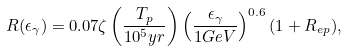<formula> <loc_0><loc_0><loc_500><loc_500>R ( \epsilon _ { \gamma } ) = 0 . 0 7 \zeta \left ( \frac { T _ { p } } { 1 0 ^ { 5 } y r } \right ) \left ( \frac { \epsilon _ { \gamma } } { 1 G e V } \right ) ^ { 0 . 6 } ( 1 + R _ { e p } ) ,</formula> 